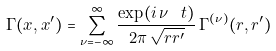Convert formula to latex. <formula><loc_0><loc_0><loc_500><loc_500>\Gamma ( x , x ^ { \prime } ) = \sum _ { \nu = - \infty } ^ { \infty } \frac { \exp ( i \, \nu \, \ t ) } { 2 \pi \, \sqrt { r r ^ { \prime } } } \, \Gamma ^ { ( \nu ) } ( r , r ^ { \prime } )</formula> 